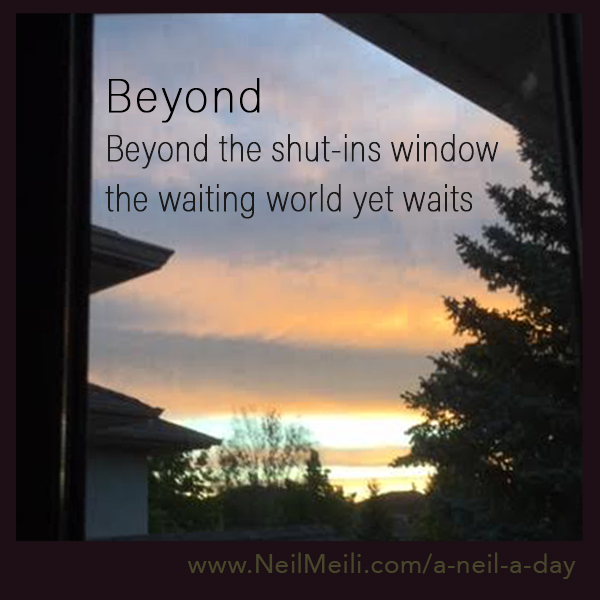If you were to imagine a story behind this image, what would it be? This image tells the story of someone who has been confined inside for a long time, perhaps due to illness or another reason. As they look out the window, they see the world waiting for them, represented by the beautiful sky at sunrise or sunset. The colors speak of hope and renewal, suggesting that even though they are within, there is a world of possibilities awaiting them beyond the window. 